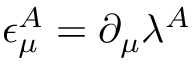<formula> <loc_0><loc_0><loc_500><loc_500>\epsilon _ { \mu } ^ { A } = \partial _ { \mu } \lambda ^ { A }</formula> 